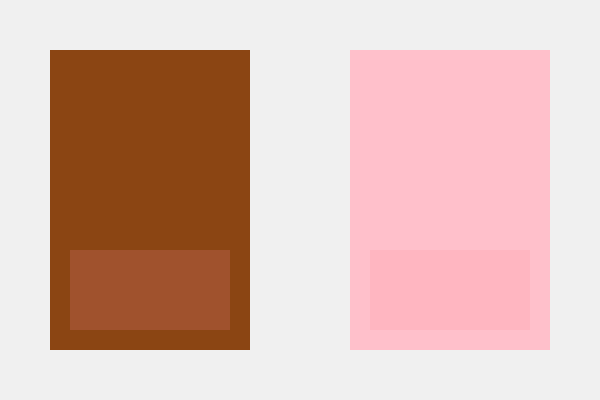Analyze the use of color in these two abstract portrait representations. How do the chosen palettes reflect and challenge traditional approaches to depicting different ethnicities in art? Consider the implications for representation and identity in your response. 1. Color Analysis:
   - Left portrait: Uses warm brown tones (hex #8B4513 and #A0522D)
   - Right portrait: Uses pink tones (hex #FFC0CB and #FFB6C1)

2. Traditional Approaches:
   - Brown tones often associated with depicting darker skin tones
   - Pink tones often used for lighter skin tones

3. Challenging Conventions:
   - The use of abstract shapes rather than realistic depictions
   - Simplified color palettes reduce individuals to basic hues

4. Representation Implications:
   - Abstraction can both highlight and obscure racial identities
   - Monochromatic approach may oversimplify complex identities

5. Identity Considerations:
   - Color choices risk reinforcing stereotypes
   - Abstract representation allows for broader interpretation

6. Artistic Intent:
   - Juxtaposition invites comparison and reflection on color in portraiture
   - Simplification may aim to provoke discussion on racial categorization

7. Cultural Context:
   - Viewer's interpretation influenced by personal and societal experiences
   - Art critic's role in unpacking these visual choices and their impact

8. Ethical Considerations:
   - Responsibility of artists and critics in representation
   - Potential for both perpetuating and challenging racial stereotypes
Answer: The color palettes simultaneously reflect traditional ethnic representations while challenging them through abstraction, inviting critical reflection on identity portrayal in art. 